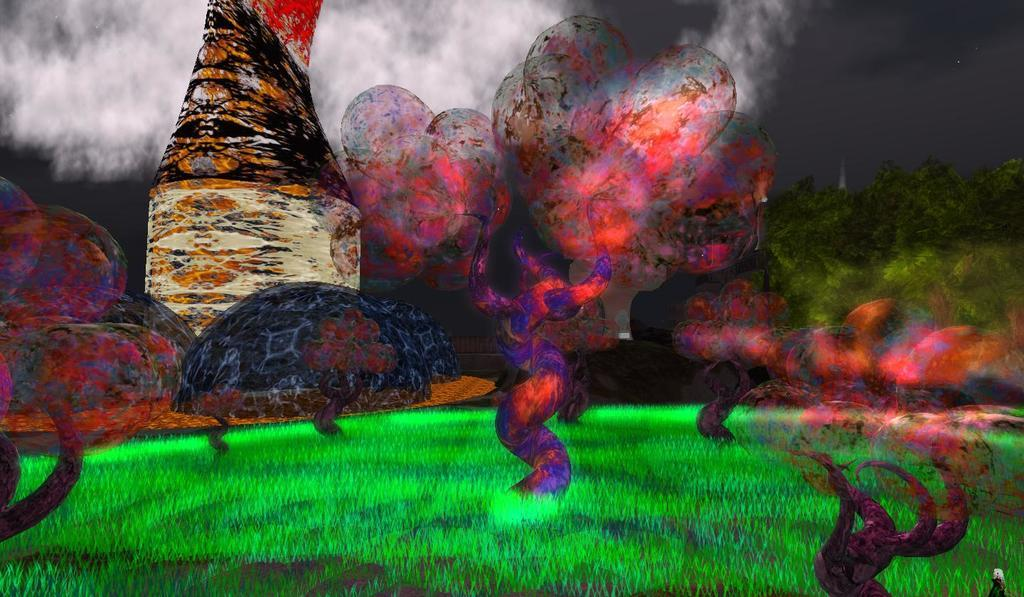What type of artwork is depicted in the image? There is a 3D painting in the image. What colors are used in the painting? The painting has different colors, including green, red, orange, pink, and other multi-colors. What type of rock can be seen in the painting? There is no rock present in the painting; it is a 3D artwork with various colors. What is the condition of the pickle in the painting? There is no pickle present in the painting; it is a 3D artwork with different colors. 